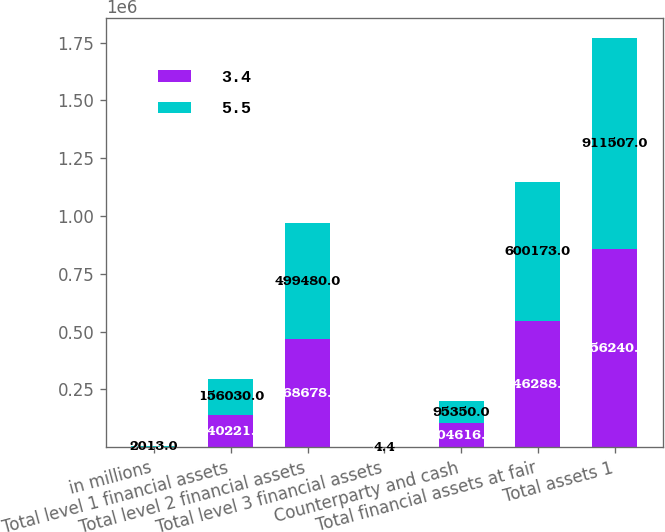<chart> <loc_0><loc_0><loc_500><loc_500><stacked_bar_chart><ecel><fcel>in millions<fcel>Total level 1 financial assets<fcel>Total level 2 financial assets<fcel>Total level 3 financial assets<fcel>Counterparty and cash<fcel>Total financial assets at fair<fcel>Total assets 1<nl><fcel>3.4<fcel>2014<fcel>140221<fcel>468678<fcel>4.9<fcel>104616<fcel>546288<fcel>856240<nl><fcel>5.5<fcel>2013<fcel>156030<fcel>499480<fcel>4.4<fcel>95350<fcel>600173<fcel>911507<nl></chart> 